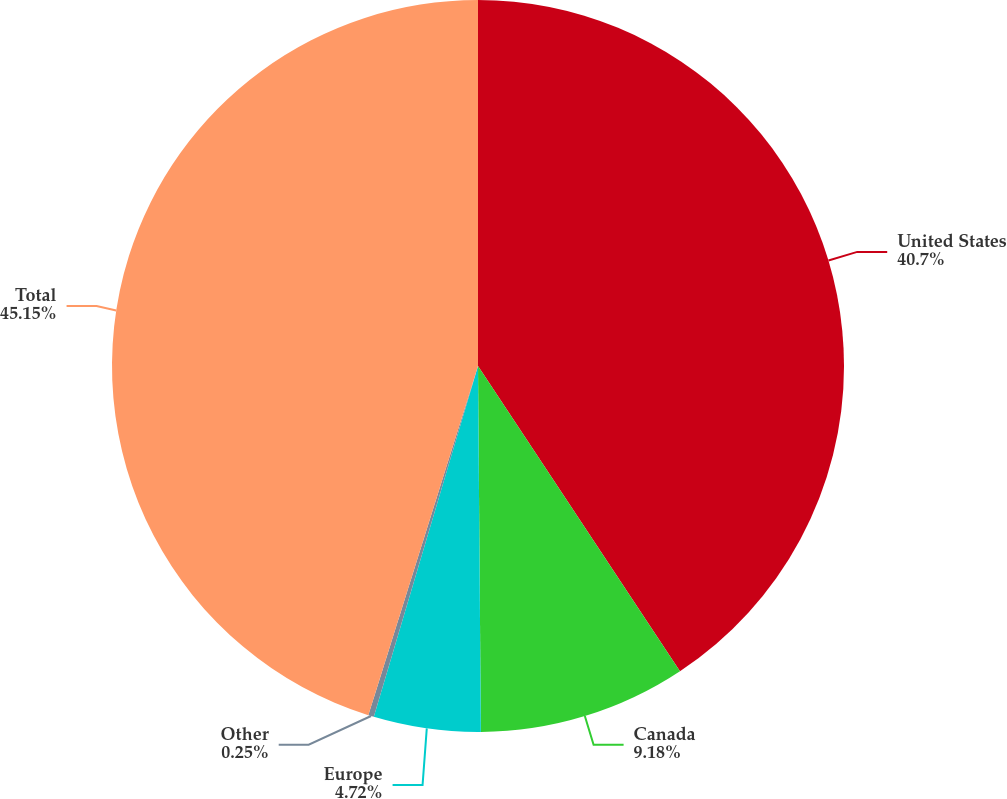Convert chart to OTSL. <chart><loc_0><loc_0><loc_500><loc_500><pie_chart><fcel>United States<fcel>Canada<fcel>Europe<fcel>Other<fcel>Total<nl><fcel>40.7%<fcel>9.18%<fcel>4.72%<fcel>0.25%<fcel>45.16%<nl></chart> 